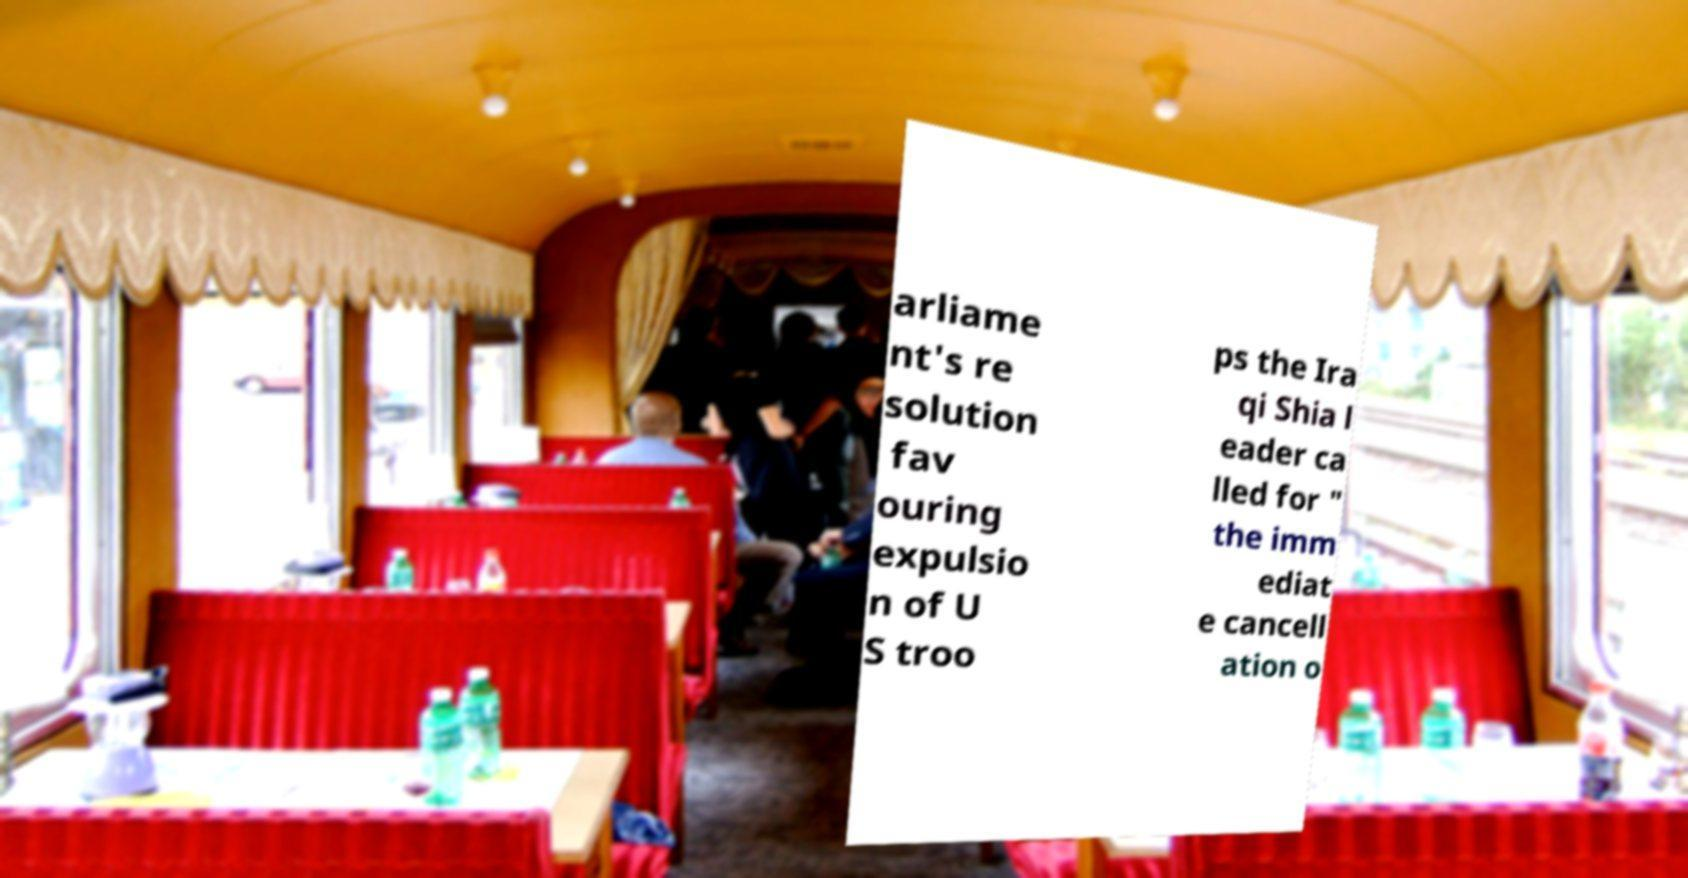Can you read and provide the text displayed in the image?This photo seems to have some interesting text. Can you extract and type it out for me? arliame nt's re solution fav ouring expulsio n of U S troo ps the Ira qi Shia l eader ca lled for " the imm ediat e cancell ation o 